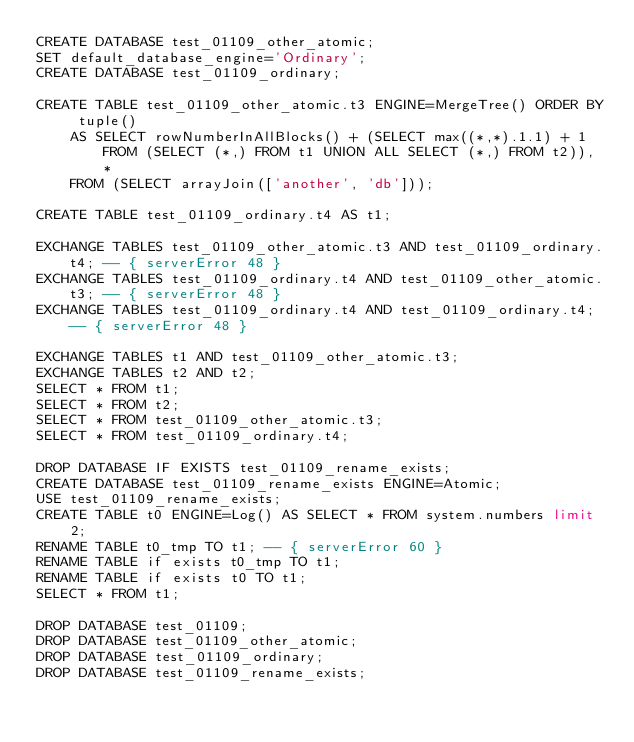<code> <loc_0><loc_0><loc_500><loc_500><_SQL_>CREATE DATABASE test_01109_other_atomic;
SET default_database_engine='Ordinary';
CREATE DATABASE test_01109_ordinary;

CREATE TABLE test_01109_other_atomic.t3 ENGINE=MergeTree() ORDER BY tuple()
    AS SELECT rowNumberInAllBlocks() + (SELECT max((*,*).1.1) + 1 FROM (SELECT (*,) FROM t1 UNION ALL SELECT (*,) FROM t2)), *
    FROM (SELECT arrayJoin(['another', 'db']));

CREATE TABLE test_01109_ordinary.t4 AS t1;

EXCHANGE TABLES test_01109_other_atomic.t3 AND test_01109_ordinary.t4; -- { serverError 48 }
EXCHANGE TABLES test_01109_ordinary.t4 AND test_01109_other_atomic.t3; -- { serverError 48 }
EXCHANGE TABLES test_01109_ordinary.t4 AND test_01109_ordinary.t4; -- { serverError 48 }

EXCHANGE TABLES t1 AND test_01109_other_atomic.t3;
EXCHANGE TABLES t2 AND t2;
SELECT * FROM t1;
SELECT * FROM t2;
SELECT * FROM test_01109_other_atomic.t3;
SELECT * FROM test_01109_ordinary.t4;

DROP DATABASE IF EXISTS test_01109_rename_exists;
CREATE DATABASE test_01109_rename_exists ENGINE=Atomic;
USE test_01109_rename_exists;
CREATE TABLE t0 ENGINE=Log() AS SELECT * FROM system.numbers limit 2;
RENAME TABLE t0_tmp TO t1; -- { serverError 60 }
RENAME TABLE if exists t0_tmp TO t1;
RENAME TABLE if exists t0 TO t1;
SELECT * FROM t1;

DROP DATABASE test_01109;
DROP DATABASE test_01109_other_atomic;
DROP DATABASE test_01109_ordinary;
DROP DATABASE test_01109_rename_exists;



</code> 